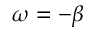Convert formula to latex. <formula><loc_0><loc_0><loc_500><loc_500>\omega = - \beta</formula> 